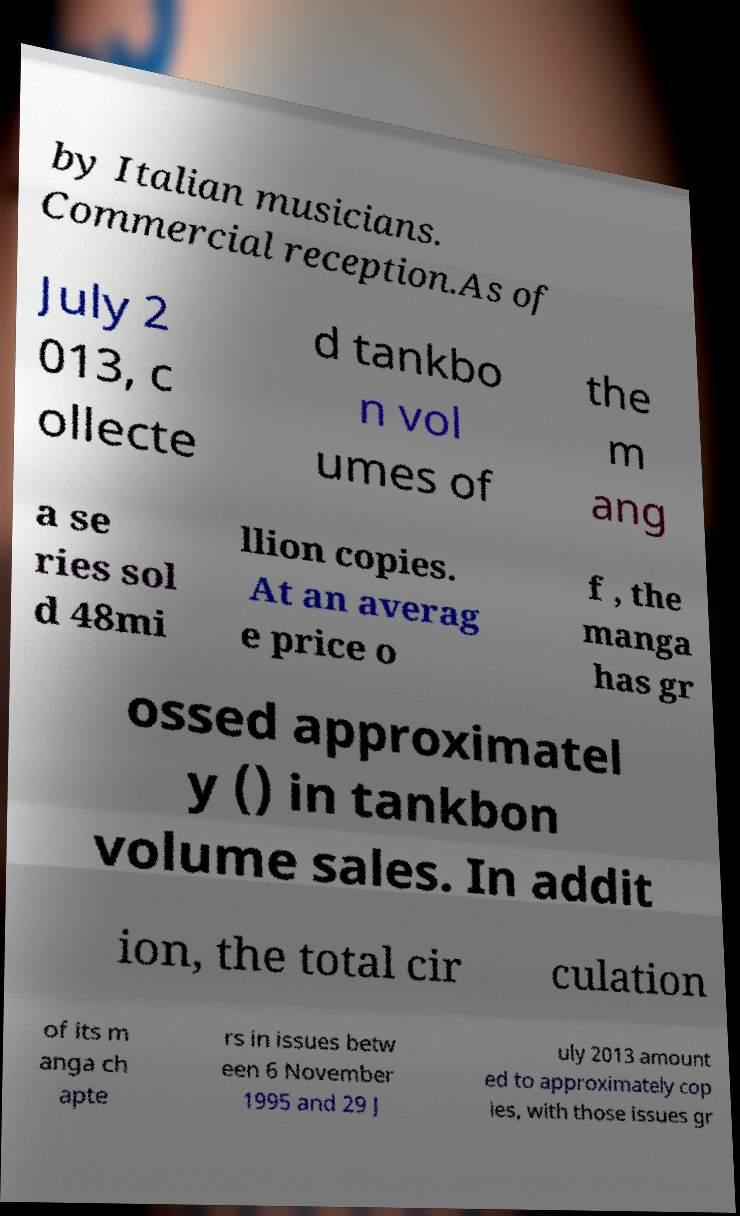Can you read and provide the text displayed in the image?This photo seems to have some interesting text. Can you extract and type it out for me? by Italian musicians. Commercial reception.As of July 2 013, c ollecte d tankbo n vol umes of the m ang a se ries sol d 48mi llion copies. At an averag e price o f , the manga has gr ossed approximatel y () in tankbon volume sales. In addit ion, the total cir culation of its m anga ch apte rs in issues betw een 6 November 1995 and 29 J uly 2013 amount ed to approximately cop ies, with those issues gr 